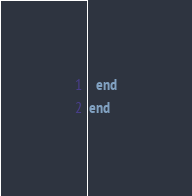<code> <loc_0><loc_0><loc_500><loc_500><_Ruby_>
  end
end
</code> 